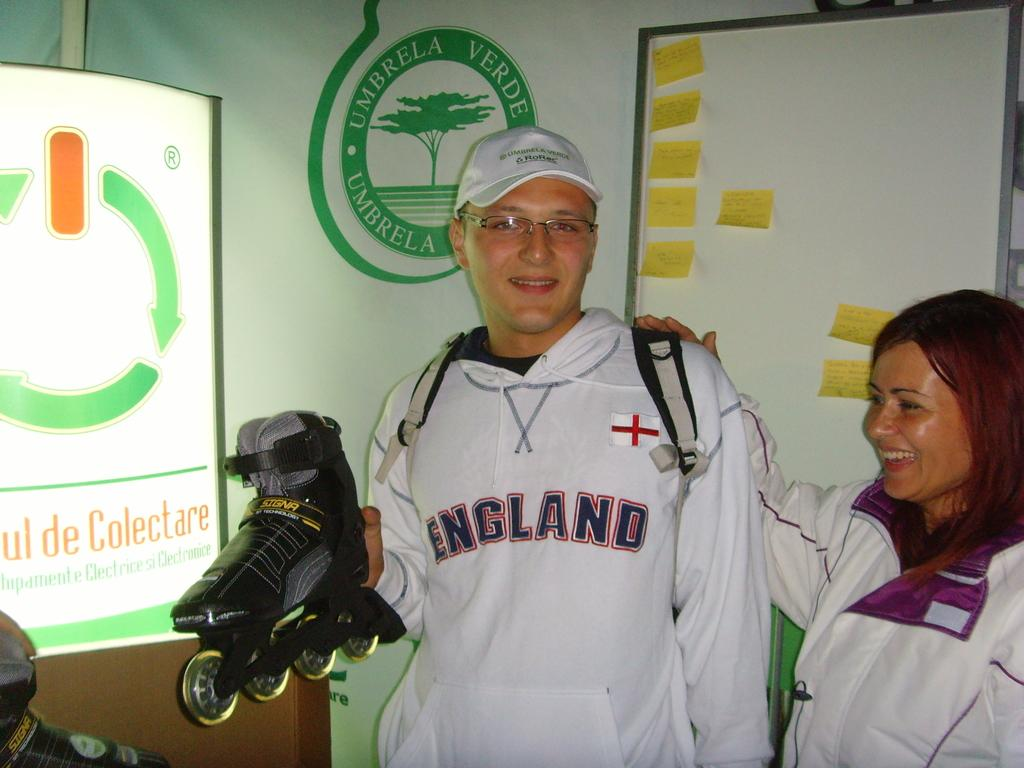Provide a one-sentence caption for the provided image. a woman and man in England hoodie standing in front of sign saying Umbrella. 